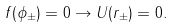Convert formula to latex. <formula><loc_0><loc_0><loc_500><loc_500>f ( \phi _ { \pm } ) = 0 \to U ( r _ { \pm } ) = 0 .</formula> 